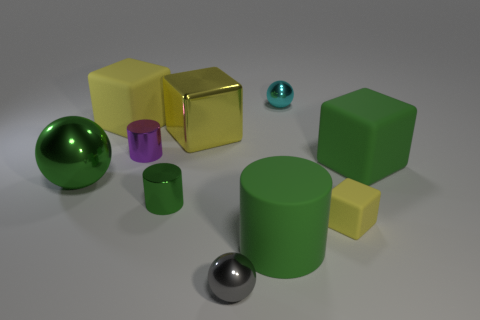How many yellow blocks must be subtracted to get 1 yellow blocks? 2 Subtract all small balls. How many balls are left? 1 Subtract all green cylinders. How many cylinders are left? 1 Subtract all spheres. How many objects are left? 7 Subtract 1 cylinders. How many cylinders are left? 2 Add 6 large green cylinders. How many large green cylinders exist? 7 Subtract 1 cyan spheres. How many objects are left? 9 Subtract all brown blocks. Subtract all brown balls. How many blocks are left? 4 Subtract all brown spheres. How many yellow cylinders are left? 0 Subtract all big matte cylinders. Subtract all tiny gray metallic balls. How many objects are left? 8 